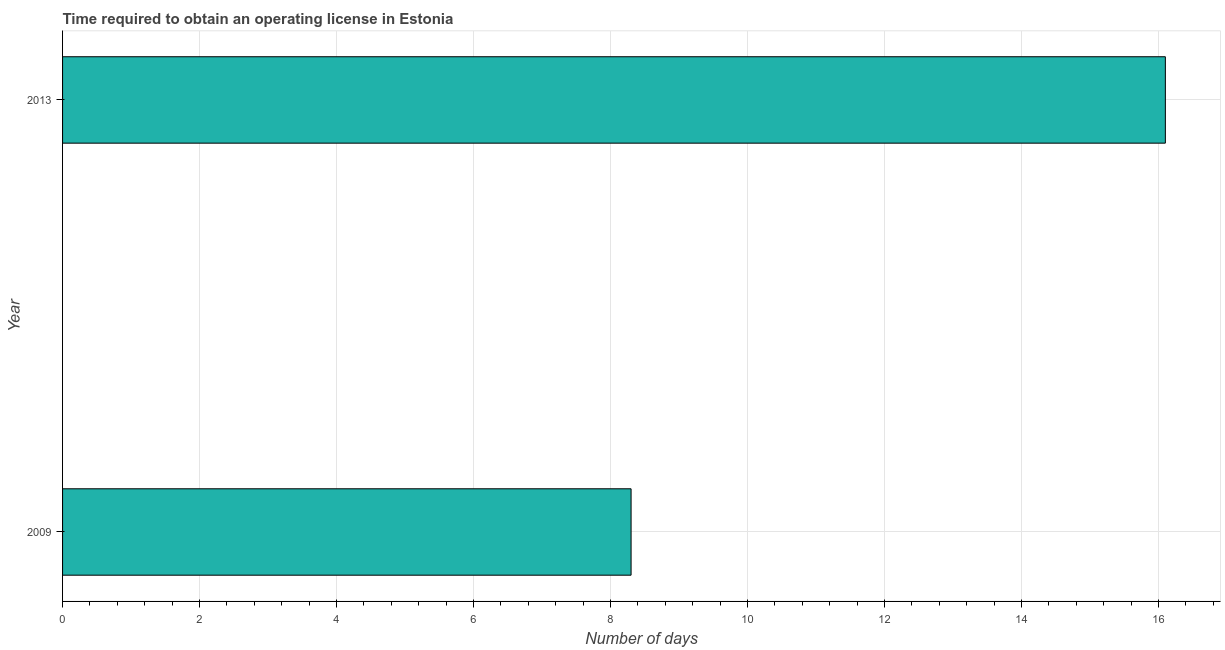Does the graph contain any zero values?
Keep it short and to the point. No. Does the graph contain grids?
Provide a short and direct response. Yes. What is the title of the graph?
Give a very brief answer. Time required to obtain an operating license in Estonia. What is the label or title of the X-axis?
Make the answer very short. Number of days. What is the number of days to obtain operating license in 2009?
Offer a terse response. 8.3. Across all years, what is the maximum number of days to obtain operating license?
Offer a very short reply. 16.1. Across all years, what is the minimum number of days to obtain operating license?
Keep it short and to the point. 8.3. What is the sum of the number of days to obtain operating license?
Provide a short and direct response. 24.4. What is the difference between the number of days to obtain operating license in 2009 and 2013?
Offer a very short reply. -7.8. What is the median number of days to obtain operating license?
Your response must be concise. 12.2. Do a majority of the years between 2009 and 2013 (inclusive) have number of days to obtain operating license greater than 6.4 days?
Keep it short and to the point. Yes. What is the ratio of the number of days to obtain operating license in 2009 to that in 2013?
Offer a very short reply. 0.52. In how many years, is the number of days to obtain operating license greater than the average number of days to obtain operating license taken over all years?
Your answer should be compact. 1. How many bars are there?
Offer a terse response. 2. Are all the bars in the graph horizontal?
Provide a short and direct response. Yes. How many years are there in the graph?
Offer a terse response. 2. What is the difference between two consecutive major ticks on the X-axis?
Keep it short and to the point. 2. Are the values on the major ticks of X-axis written in scientific E-notation?
Your answer should be compact. No. What is the Number of days of 2009?
Your response must be concise. 8.3. What is the Number of days in 2013?
Give a very brief answer. 16.1. What is the difference between the Number of days in 2009 and 2013?
Your response must be concise. -7.8. What is the ratio of the Number of days in 2009 to that in 2013?
Your answer should be very brief. 0.52. 